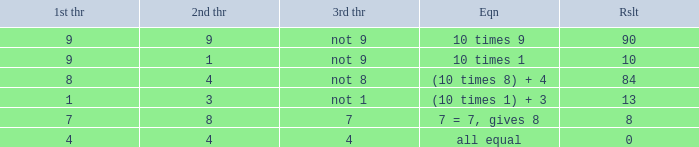What is the result when the 3rd throw is not 8? 84.0. 